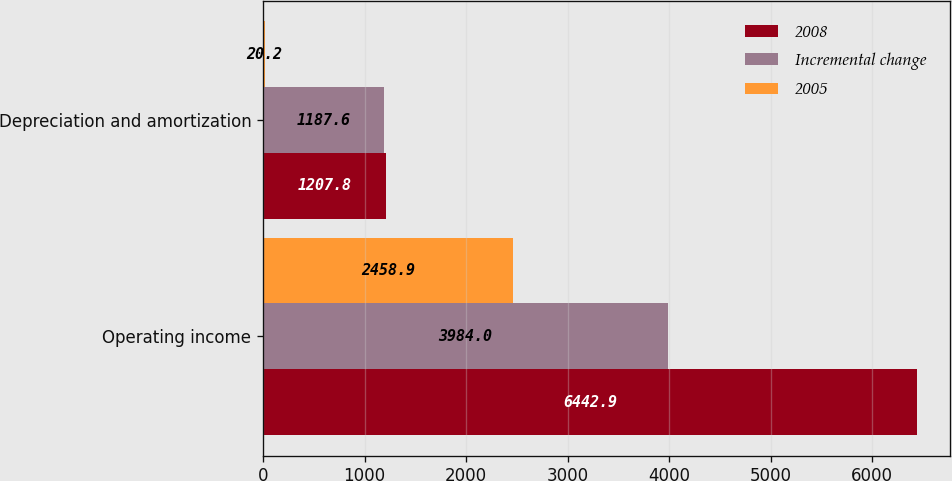Convert chart. <chart><loc_0><loc_0><loc_500><loc_500><stacked_bar_chart><ecel><fcel>Operating income<fcel>Depreciation and amortization<nl><fcel>2008<fcel>6442.9<fcel>1207.8<nl><fcel>Incremental change<fcel>3984<fcel>1187.6<nl><fcel>2005<fcel>2458.9<fcel>20.2<nl></chart> 